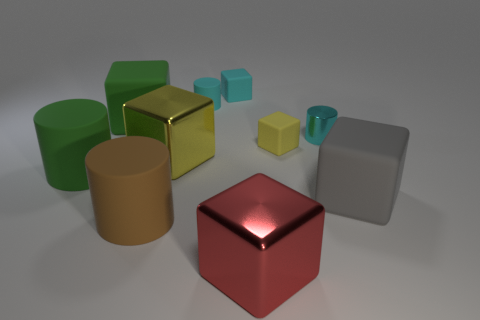Subtract 1 cubes. How many cubes are left? 5 Subtract all large green rubber cubes. How many cubes are left? 5 Subtract all red cubes. How many cubes are left? 5 Subtract all green cubes. Subtract all purple balls. How many cubes are left? 5 Subtract all cylinders. How many objects are left? 6 Add 4 large yellow objects. How many large yellow objects exist? 5 Subtract 2 yellow cubes. How many objects are left? 8 Subtract all brown rubber objects. Subtract all small blocks. How many objects are left? 7 Add 6 small yellow blocks. How many small yellow blocks are left? 7 